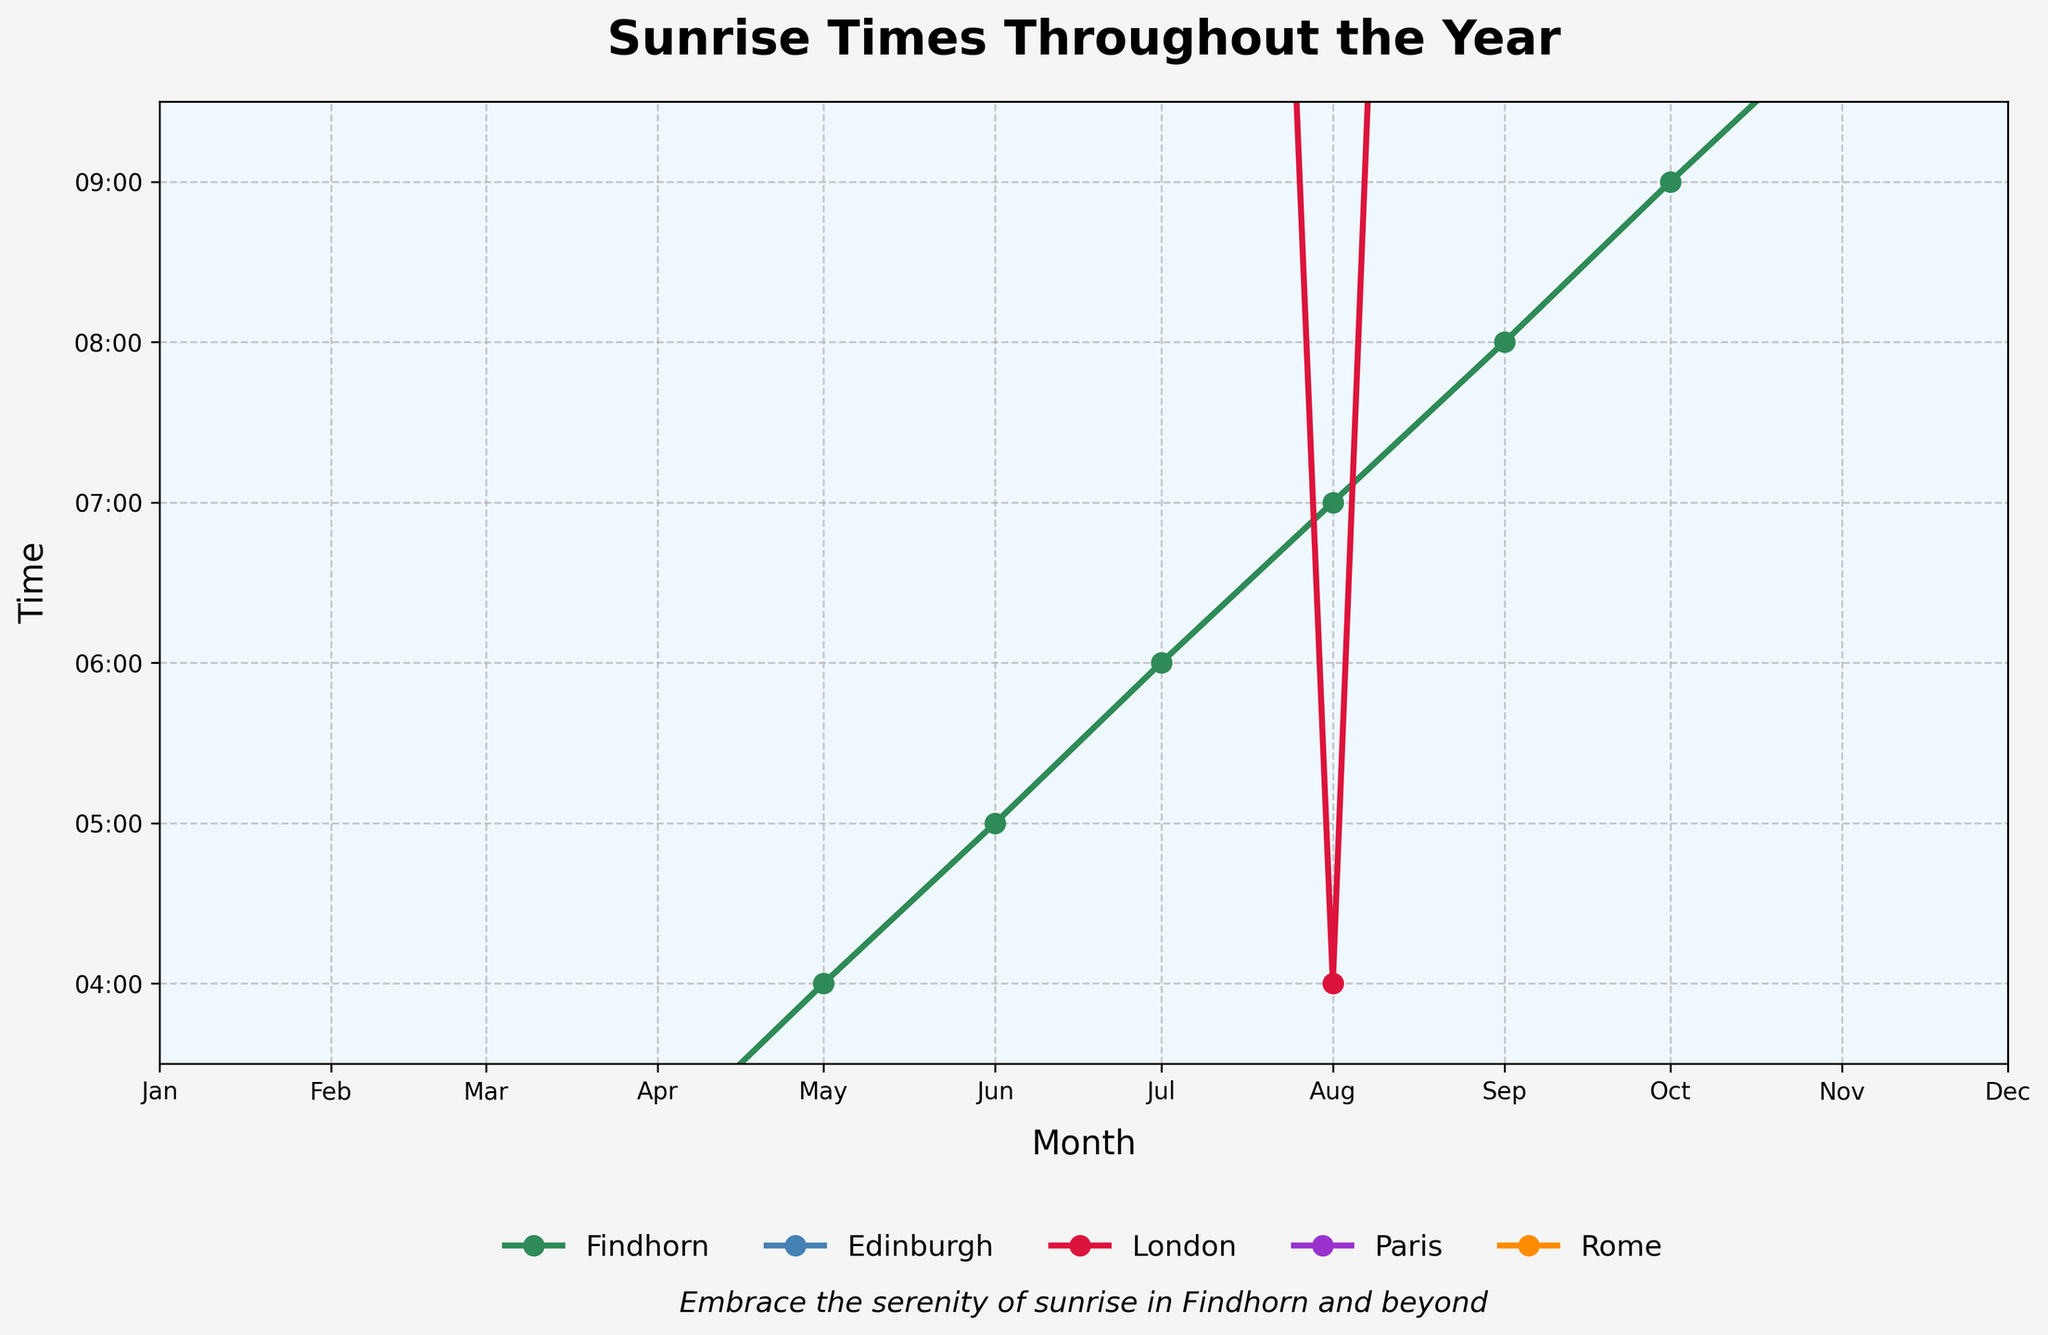Which month has the earliest sunrise in Findhorn? Look at the lowest point on the Findhorn line in the chart. The earliest sunrise time in Findhorn occurs in July at 04:15.
Answer: July Which city has the earliest sunrise time in June? Compare the plotted lines in June. Findhorn has the earliest sunrise time in June at 04:24.
Answer: Findhorn During which month does London experience its latest sunrise? Check the London plot and find the highest point of the curve. London's latest sunrise is at 08:06 in January.
Answer: January How does the sunrise time in Paris in October compare to Findhorn in October? In October, Findhorn’s sunrise is plotted at around 07:22, while Paris’s is at 07:54. Paris's sunrise is later than Findhorn’s.
Answer: Paris's sunrise is later On average, how much later does the sun rise in Findhorn compared to Rome in January and December? Findhorn's sunrise in January is at 08:57 and in December at 08:38. Rome’s in January is at 07:36 and in December at 07:20. Calculate the average difference: \[((08:57 - 07:36) + (08:38 - 07:20)) / 2 = (1h 21m + 1h 18m) / 2 = 1h 19.5m\].
Answer: About 1 hour and 20 minutes What is the time difference between the earliest sunrise in Findhorn and the earliest sunrise in Paris within the recorded months? Findhorn's earliest sunrise is at 04:15 in July. Paris’s earliest is at 05:49 in June. The difference is \(05:49 - 04:15 = 1h 34m\).
Answer: 1 hour and 34 minutes In which month are the sunrise times for all cities closest to each other? Look at the points where the lines converge the closest. In March, the times are 07:08 (Findhorn), 06:59 (Edinburgh), 06:39 (London), 07:14 (Paris), 06:41 (Rome). They are all within 35 minutes of each other.
Answer: March Which city has the latest sunrise in November? Check the plotted lines for November and see which is the highest. Paris has the latest sunrise at 07:38 in November.
Answer: Paris Calculate the difference in sunrise times between Edinburgh and London in Sep and Dec, then find the average difference In September, Edinburgh is at 06:12 and London at 06:15. In December, Edinburgh is at 08:25 and London at 07:45. Differences are \((06:15 - 06:12) = 3 min\) and \((08:25 - 07:45) = 40 min\). Average: \((3 + 40)/2 = 21.5 min\).
Answer: 21.5 minutes During which month does Findhorn have the same sunrise time as Paris? Compare the plots, Findhorn and Paris both have a sunrise of 07:14 in March.
Answer: March 